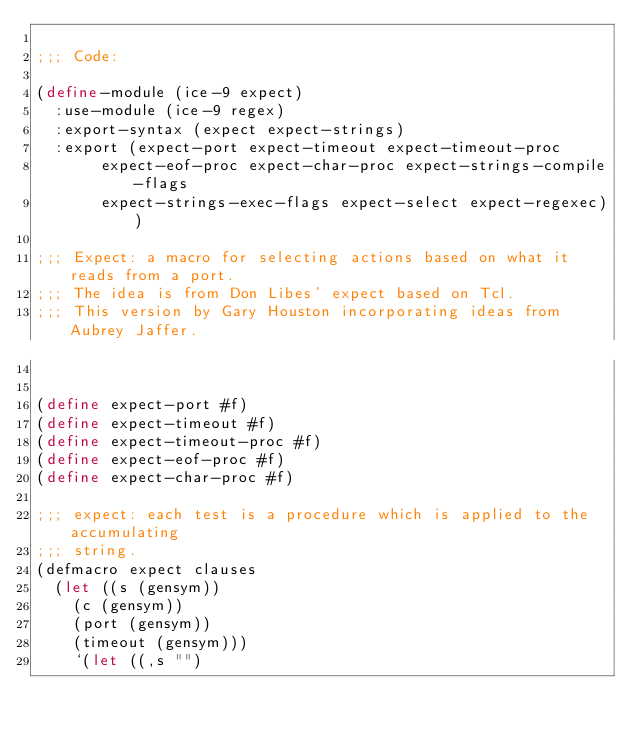Convert code to text. <code><loc_0><loc_0><loc_500><loc_500><_Scheme_>
;;; Code:

(define-module (ice-9 expect)
  :use-module (ice-9 regex)
  :export-syntax (expect expect-strings)
  :export (expect-port expect-timeout expect-timeout-proc
	   expect-eof-proc expect-char-proc expect-strings-compile-flags
	   expect-strings-exec-flags expect-select expect-regexec))

;;; Expect: a macro for selecting actions based on what it reads from a port.
;;; The idea is from Don Libes' expect based on Tcl.
;;; This version by Gary Houston incorporating ideas from Aubrey Jaffer.


(define expect-port #f)
(define expect-timeout #f)
(define expect-timeout-proc #f)
(define expect-eof-proc #f)
(define expect-char-proc #f)

;;; expect: each test is a procedure which is applied to the accumulating
;;; string.
(defmacro expect clauses
  (let ((s (gensym))
	(c (gensym))
	(port (gensym))
	(timeout (gensym)))
    `(let ((,s "")</code> 